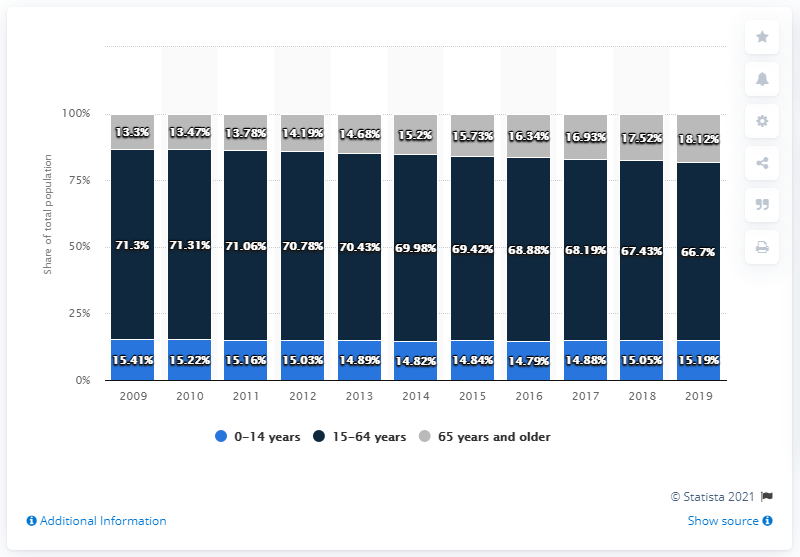List a handful of essential elements in this visual. Is the grey bar always shorter than the dark blue bar across all years? The answer is yes. In 2019, the average age of the population between 15 and 64 years was approximately 34.815 years. The population aged 65 years and older was significantly lower than that of the population aged 0 to 14 years, which indicates a distribution of age groups in the population. 